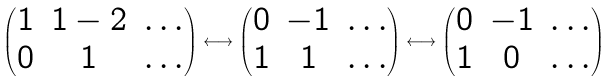Convert formula to latex. <formula><loc_0><loc_0><loc_500><loc_500>\left ( \begin{matrix} 1 & 1 - 2 & \dots \\ 0 & 1 & \dots \end{matrix} \right ) \longleftrightarrow \left ( \begin{matrix} 0 & - 1 & \dots \\ 1 & 1 & \dots \end{matrix} \right ) \longleftrightarrow \left ( \begin{matrix} 0 & - 1 & \dots \\ 1 & 0 & \dots \end{matrix} \right )</formula> 